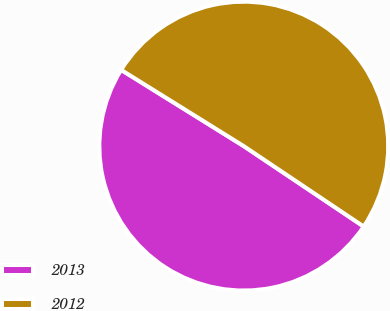<chart> <loc_0><loc_0><loc_500><loc_500><pie_chart><fcel>2013<fcel>2012<nl><fcel>49.45%<fcel>50.55%<nl></chart> 